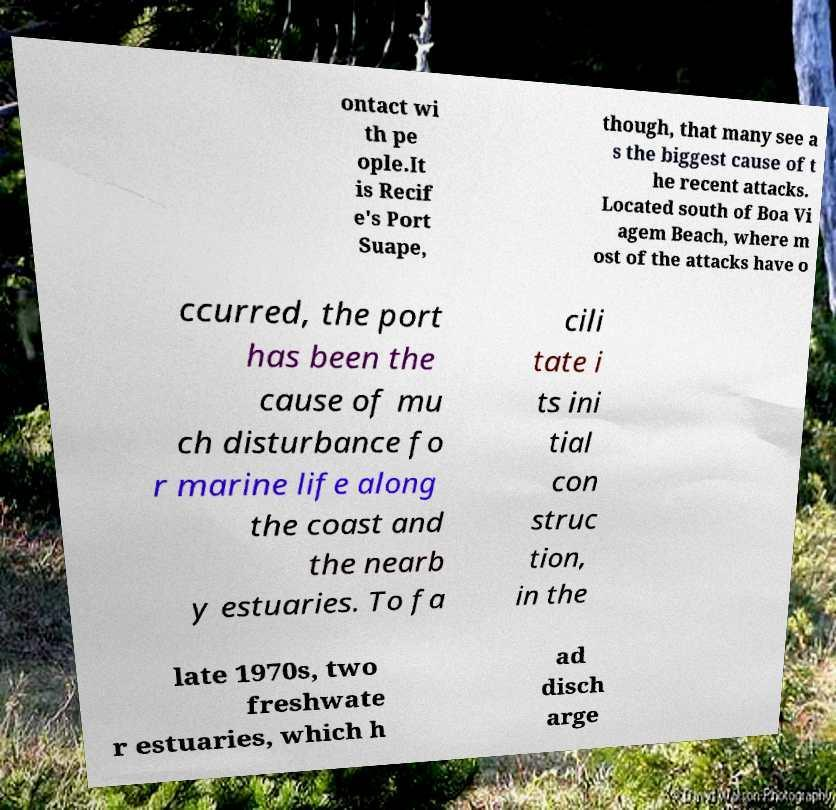Could you assist in decoding the text presented in this image and type it out clearly? ontact wi th pe ople.It is Recif e's Port Suape, though, that many see a s the biggest cause of t he recent attacks. Located south of Boa Vi agem Beach, where m ost of the attacks have o ccurred, the port has been the cause of mu ch disturbance fo r marine life along the coast and the nearb y estuaries. To fa cili tate i ts ini tial con struc tion, in the late 1970s, two freshwate r estuaries, which h ad disch arge 